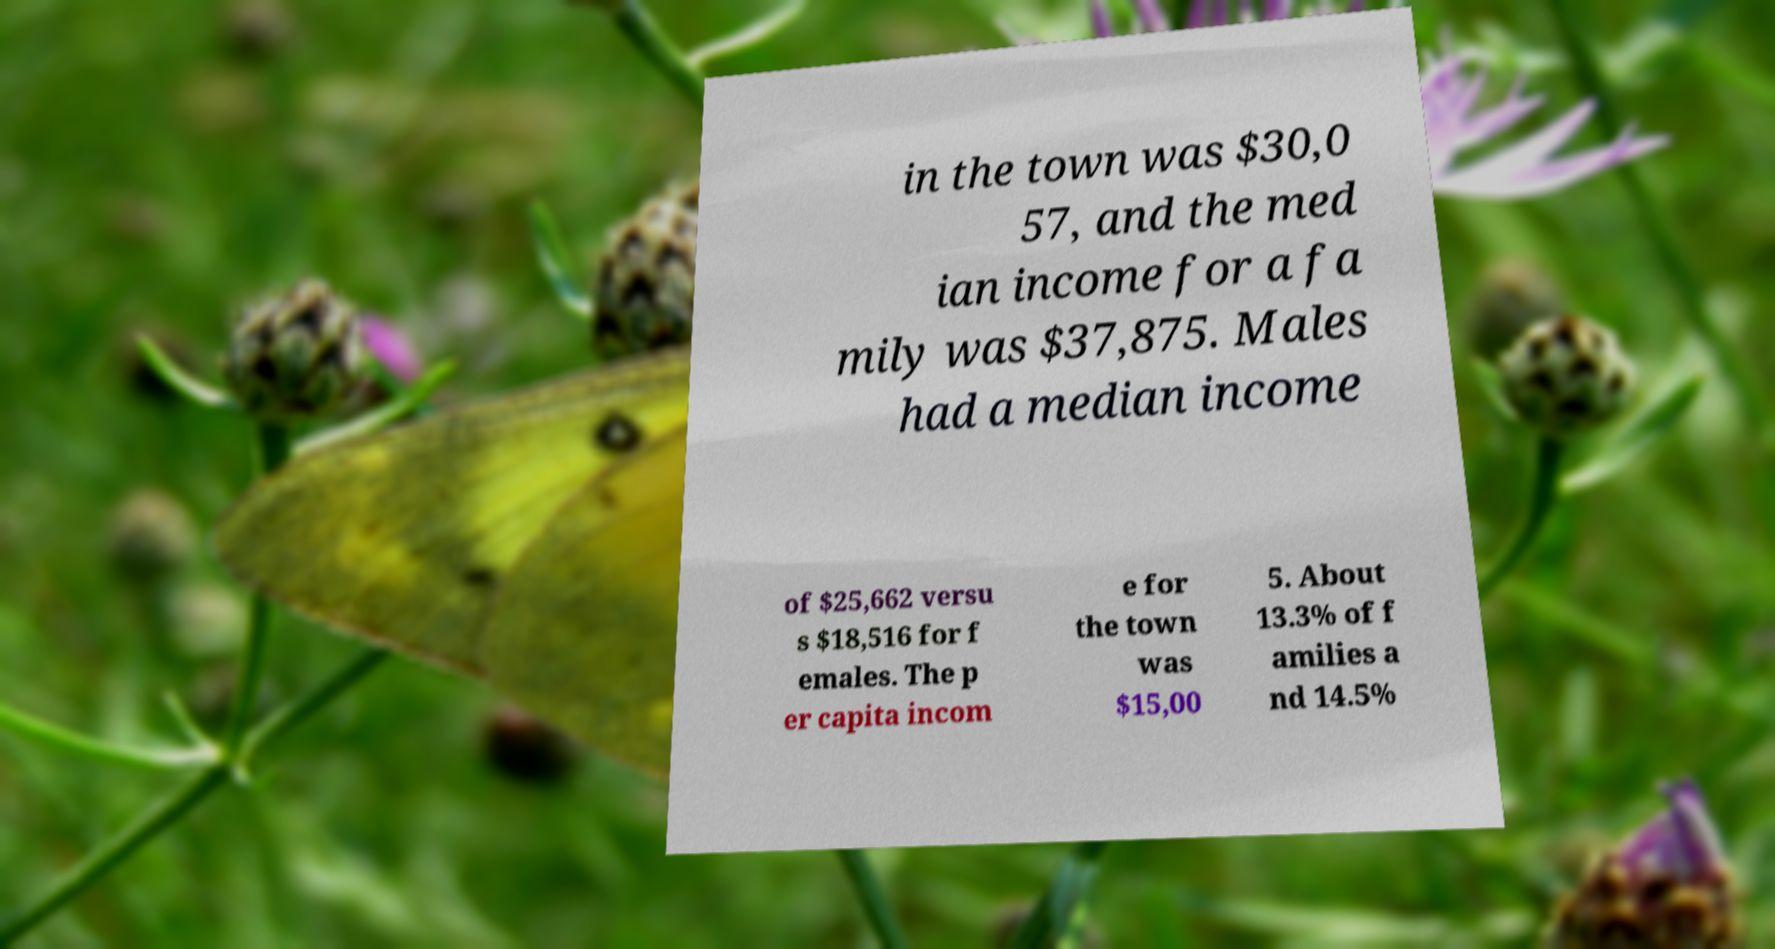For documentation purposes, I need the text within this image transcribed. Could you provide that? in the town was $30,0 57, and the med ian income for a fa mily was $37,875. Males had a median income of $25,662 versu s $18,516 for f emales. The p er capita incom e for the town was $15,00 5. About 13.3% of f amilies a nd 14.5% 